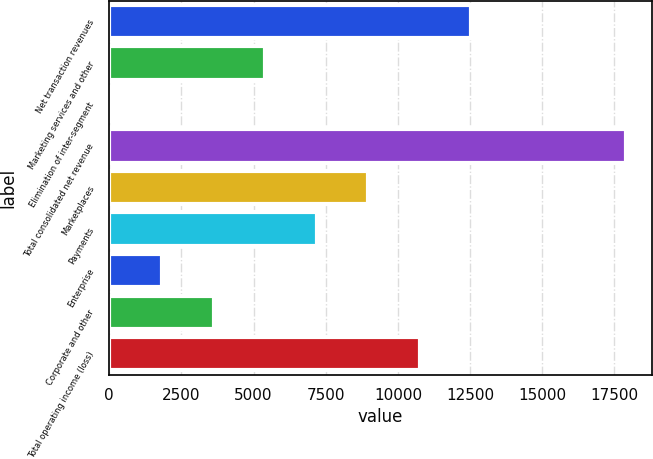Convert chart to OTSL. <chart><loc_0><loc_0><loc_500><loc_500><bar_chart><fcel>Net transaction revenues<fcel>Marketing services and other<fcel>Elimination of inter-segment<fcel>Total consolidated net revenue<fcel>Marketplaces<fcel>Payments<fcel>Enterprise<fcel>Corporate and other<fcel>Total operating income (loss)<nl><fcel>12548.5<fcel>5410.5<fcel>57<fcel>17902<fcel>8979.5<fcel>7195<fcel>1841.5<fcel>3626<fcel>10764<nl></chart> 